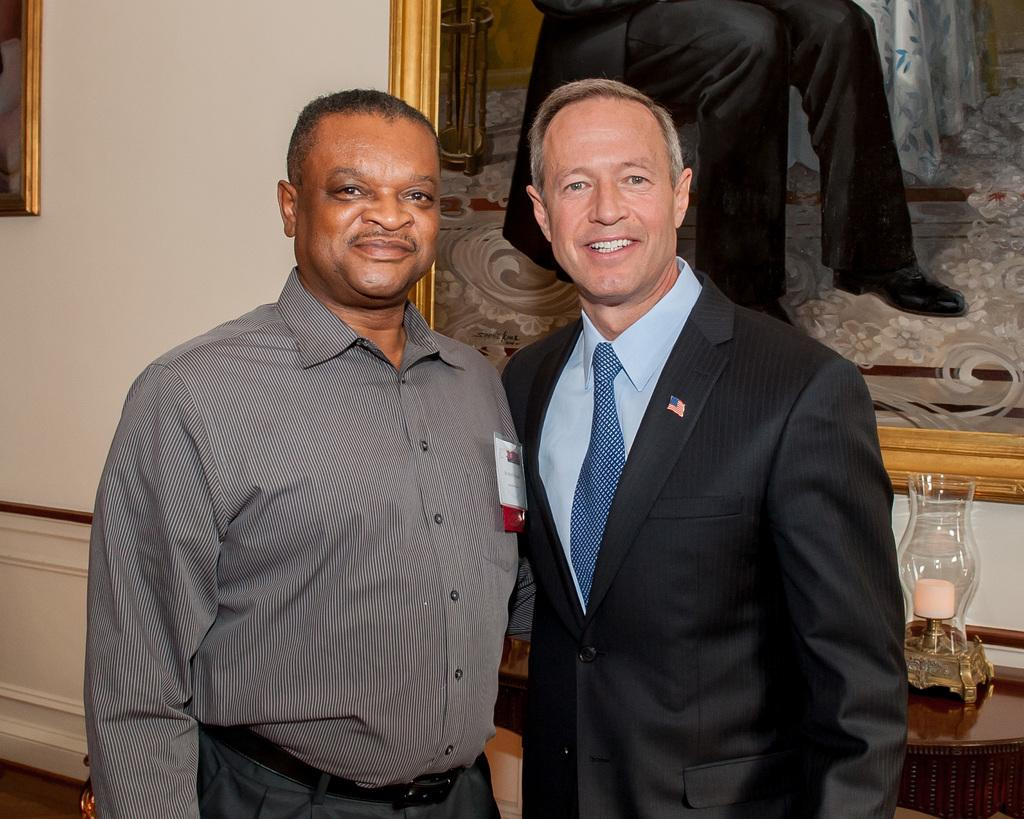How many people are in the image? There are two persons in the image. What are the persons wearing? The persons are wearing clothes. What can be seen on the wall in the image? There is a photo frame on the wall. Where is the lamp located in the image? The lamp is in the bottom right of the image. What is the tongue doing in the image? There is no tongue present in the image. How does the digestion process appear in the image? The image does not depict any digestion process; it features two persons, a photo frame, and a lamp. 